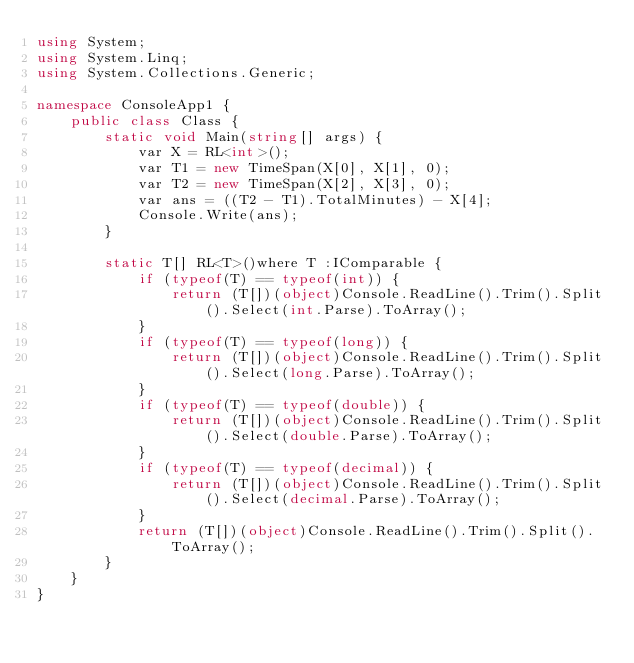Convert code to text. <code><loc_0><loc_0><loc_500><loc_500><_C#_>using System;
using System.Linq;
using System.Collections.Generic;

namespace ConsoleApp1 {
    public class Class {
        static void Main(string[] args) {
            var X = RL<int>();
            var T1 = new TimeSpan(X[0], X[1], 0);
            var T2 = new TimeSpan(X[2], X[3], 0);
            var ans = ((T2 - T1).TotalMinutes) - X[4];
            Console.Write(ans);
        }

        static T[] RL<T>()where T :IComparable {
            if (typeof(T) == typeof(int)) {
                return (T[])(object)Console.ReadLine().Trim().Split().Select(int.Parse).ToArray();
            }
            if (typeof(T) == typeof(long)) {
                return (T[])(object)Console.ReadLine().Trim().Split().Select(long.Parse).ToArray();
            }
            if (typeof(T) == typeof(double)) {
                return (T[])(object)Console.ReadLine().Trim().Split().Select(double.Parse).ToArray();
            }
            if (typeof(T) == typeof(decimal)) {
                return (T[])(object)Console.ReadLine().Trim().Split().Select(decimal.Parse).ToArray();
            }
            return (T[])(object)Console.ReadLine().Trim().Split().ToArray();
        }
    }
}</code> 